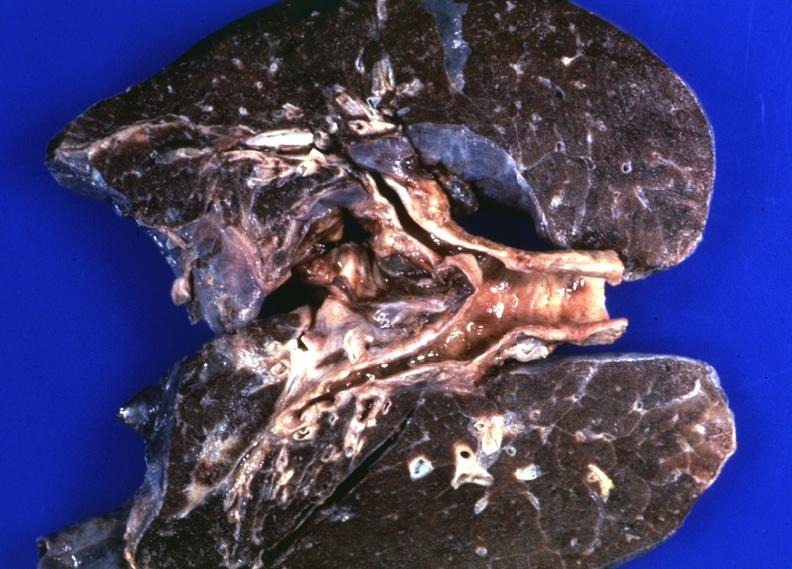does this image show lungs, hemochromatosis?
Answer the question using a single word or phrase. Yes 